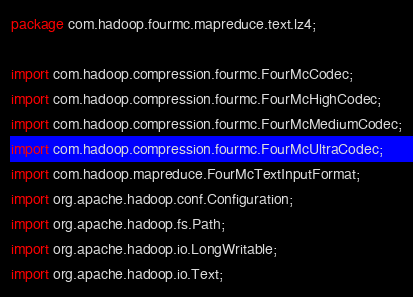Convert code to text. <code><loc_0><loc_0><loc_500><loc_500><_Java_>package com.hadoop.fourmc.mapreduce.text.lz4;

import com.hadoop.compression.fourmc.FourMcCodec;
import com.hadoop.compression.fourmc.FourMcHighCodec;
import com.hadoop.compression.fourmc.FourMcMediumCodec;
import com.hadoop.compression.fourmc.FourMcUltraCodec;
import com.hadoop.mapreduce.FourMcTextInputFormat;
import org.apache.hadoop.conf.Configuration;
import org.apache.hadoop.fs.Path;
import org.apache.hadoop.io.LongWritable;
import org.apache.hadoop.io.Text;</code> 